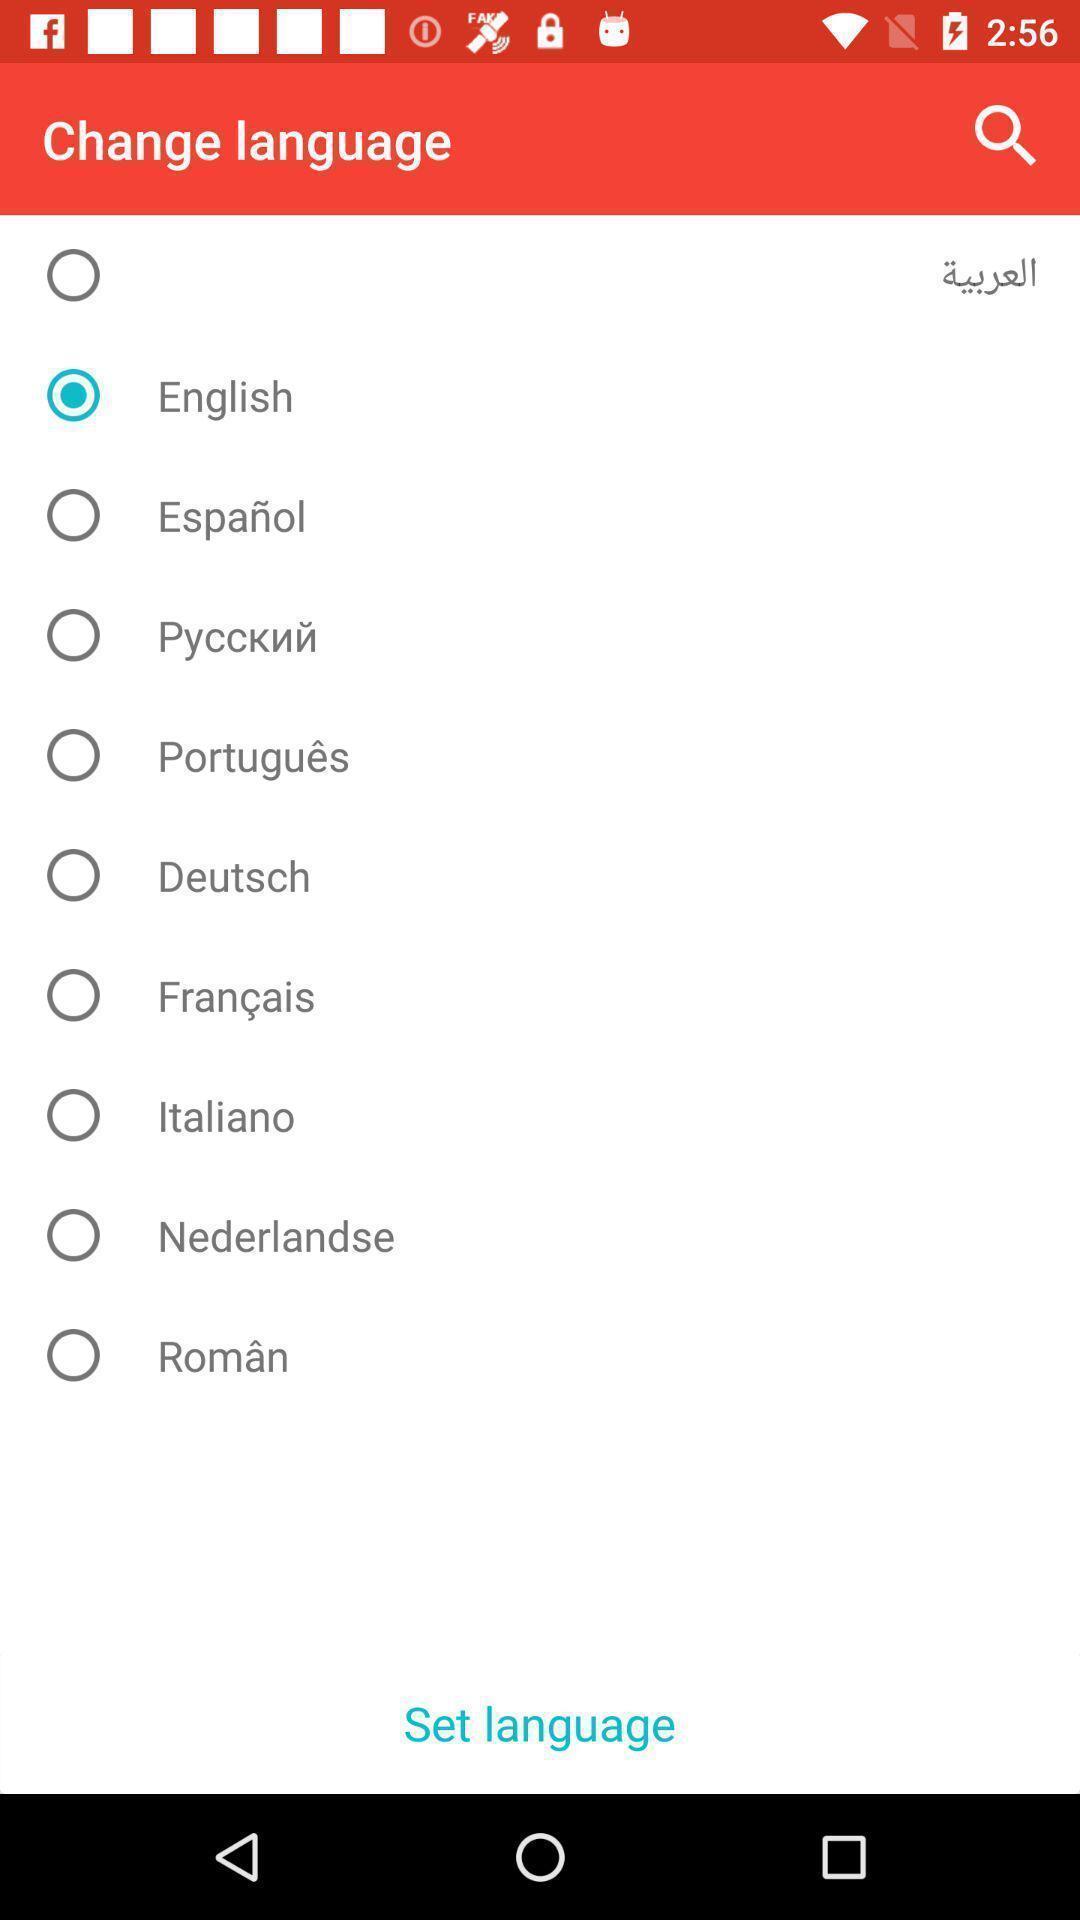Provide a description of this screenshot. Screen shows change languages. 